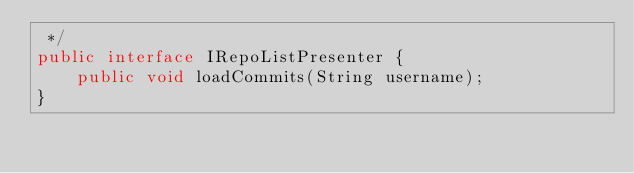Convert code to text. <code><loc_0><loc_0><loc_500><loc_500><_Java_> */
public interface IRepoListPresenter {
    public void loadCommits(String username);
}
</code> 